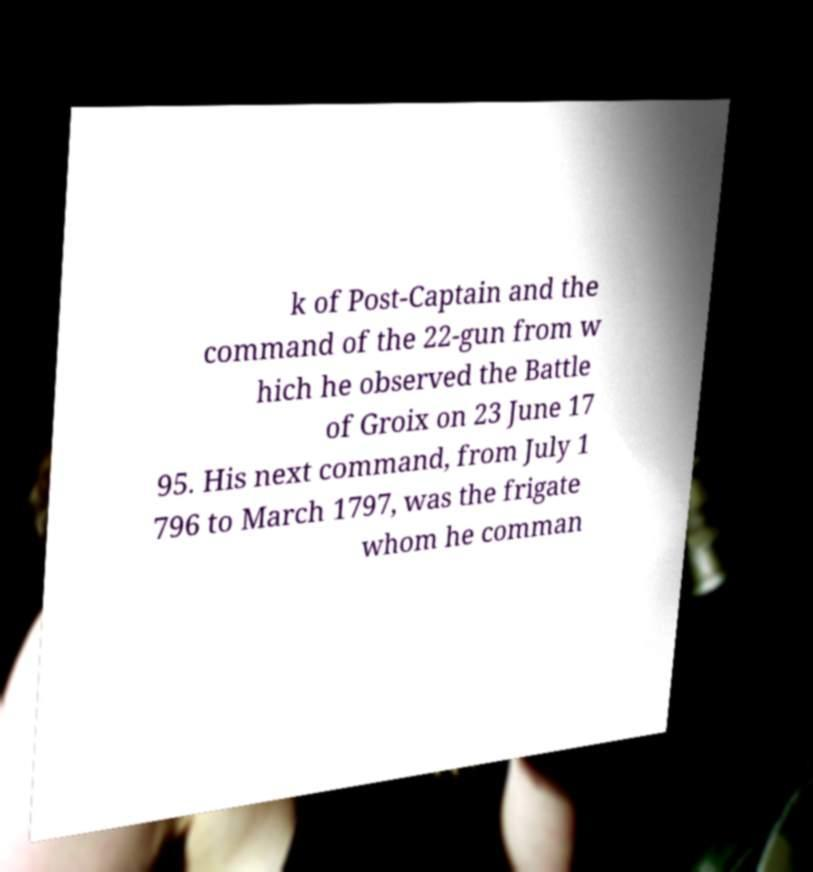What messages or text are displayed in this image? I need them in a readable, typed format. k of Post-Captain and the command of the 22-gun from w hich he observed the Battle of Groix on 23 June 17 95. His next command, from July 1 796 to March 1797, was the frigate whom he comman 